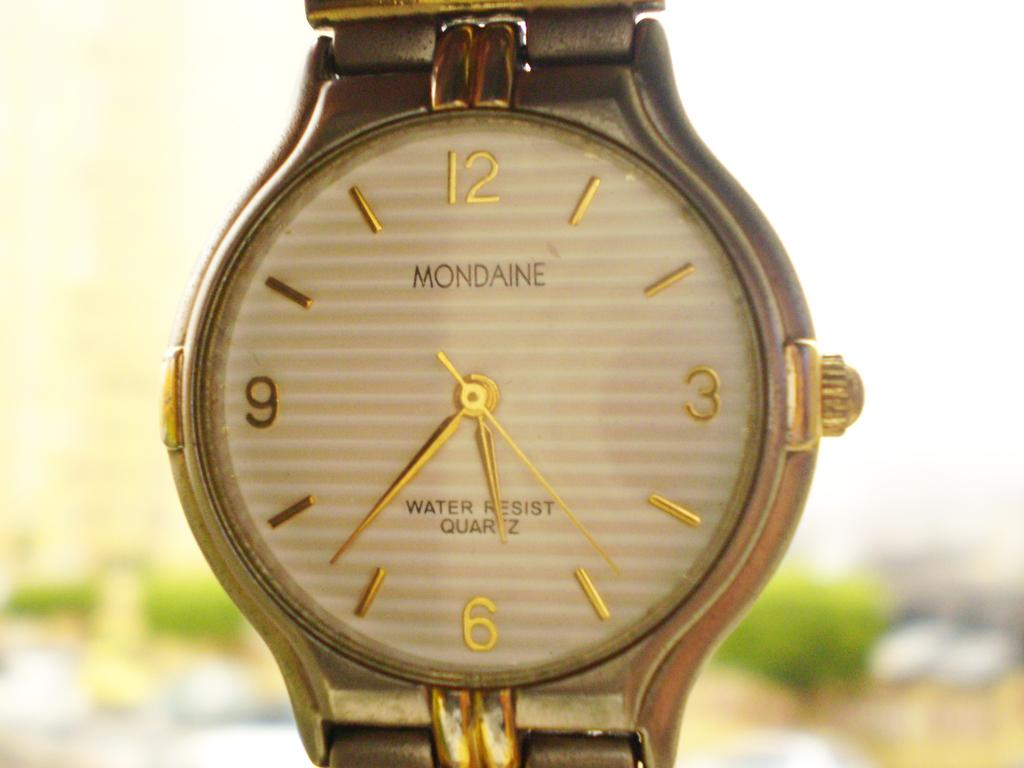<image>
Render a clear and concise summary of the photo. MODAINE is the name brand of the watch. 